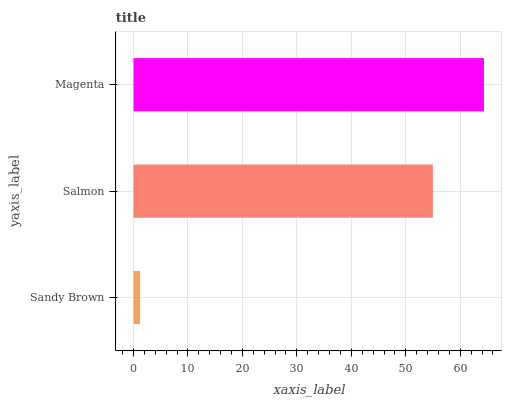Is Sandy Brown the minimum?
Answer yes or no. Yes. Is Magenta the maximum?
Answer yes or no. Yes. Is Salmon the minimum?
Answer yes or no. No. Is Salmon the maximum?
Answer yes or no. No. Is Salmon greater than Sandy Brown?
Answer yes or no. Yes. Is Sandy Brown less than Salmon?
Answer yes or no. Yes. Is Sandy Brown greater than Salmon?
Answer yes or no. No. Is Salmon less than Sandy Brown?
Answer yes or no. No. Is Salmon the high median?
Answer yes or no. Yes. Is Salmon the low median?
Answer yes or no. Yes. Is Magenta the high median?
Answer yes or no. No. Is Sandy Brown the low median?
Answer yes or no. No. 